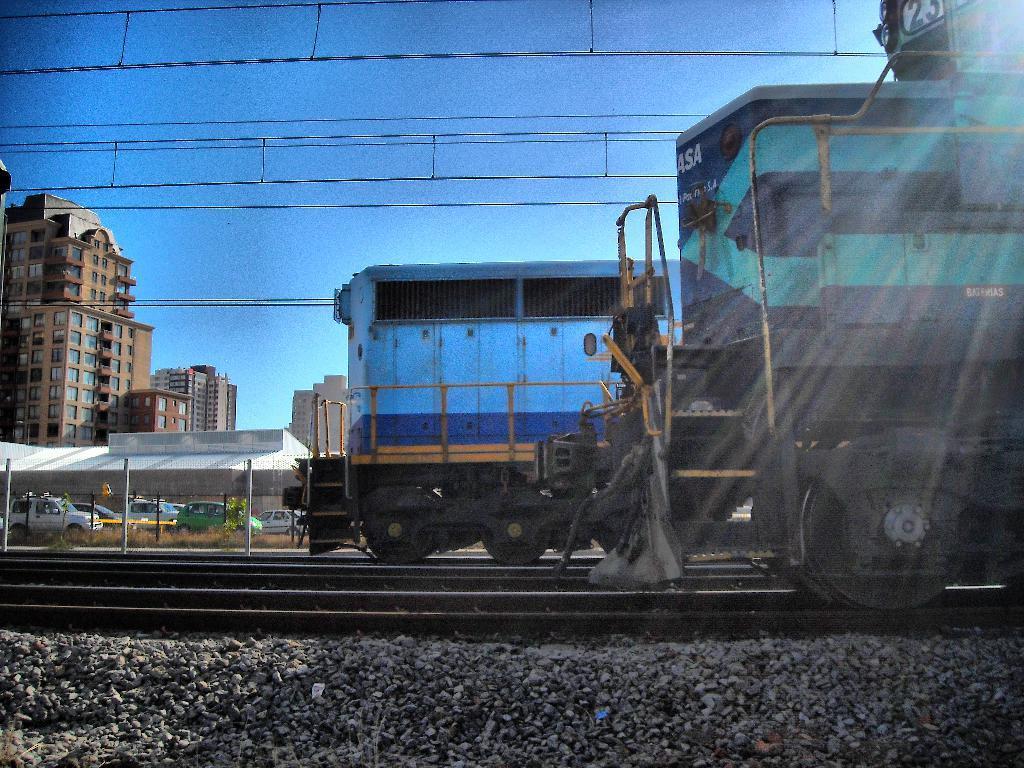Please provide a concise description of this image. In this image there are trains on the railway tracks, and in the background there are vehicles,grass, buildings, cables,sky. 